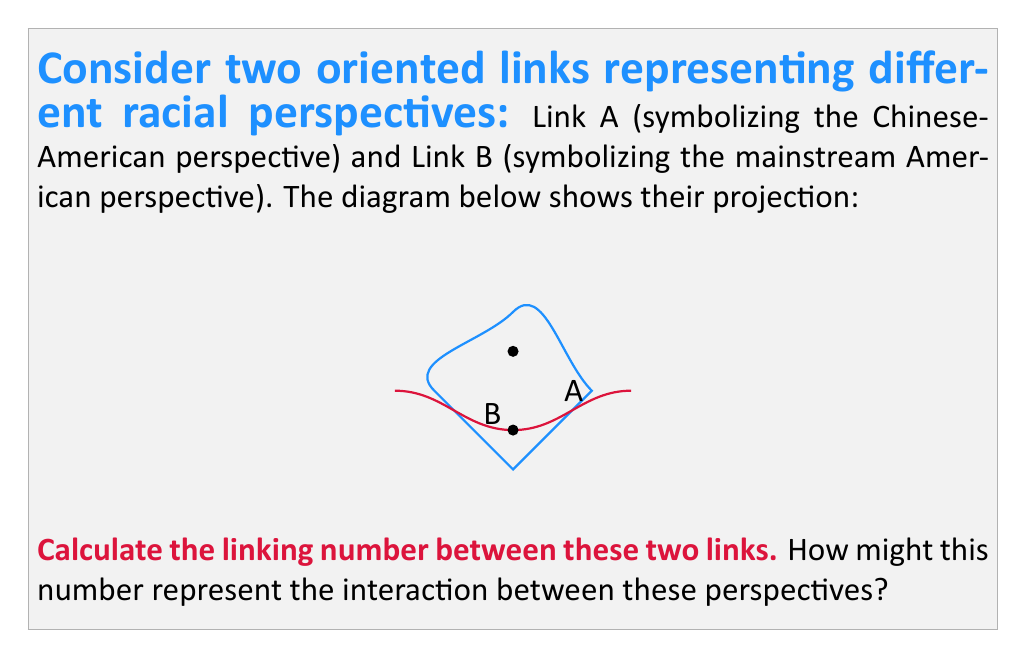Could you help me with this problem? To calculate the linking number between two oriented links, we follow these steps:

1) Identify the crossings where one link passes over the other.
2) Assign a value of +1 or -1 to each crossing based on its orientation.
3) Sum these values and divide by 2 to get the linking number.

In this diagram:

1) We have two crossings where Link B (red) passes under Link A (blue).

2) To determine the sign of each crossing:
   - At the lower crossing: Link A is moving right to left, Link B is moving left to right. This forms a right-hand screw, so it's positive (+1).
   - At the upper crossing: Link A is moving left to right, Link B is moving left to right. This forms a left-hand screw, so it's negative (-1).

3) Summing the crossings: (+1) + (-1) = 0

4) Dividing by 2: $\frac{0}{2} = 0$

Therefore, the linking number is 0.

Interpretation: A linking number of 0 suggests that while the two perspectives (Chinese-American and mainstream American) interact, they don't fundamentally alter each other's "path" or essence. This could represent a situation where the two perspectives coexist but don't deeply influence each other, highlighting the need for more meaningful dialogue and understanding between different racial perspectives.
Answer: 0 